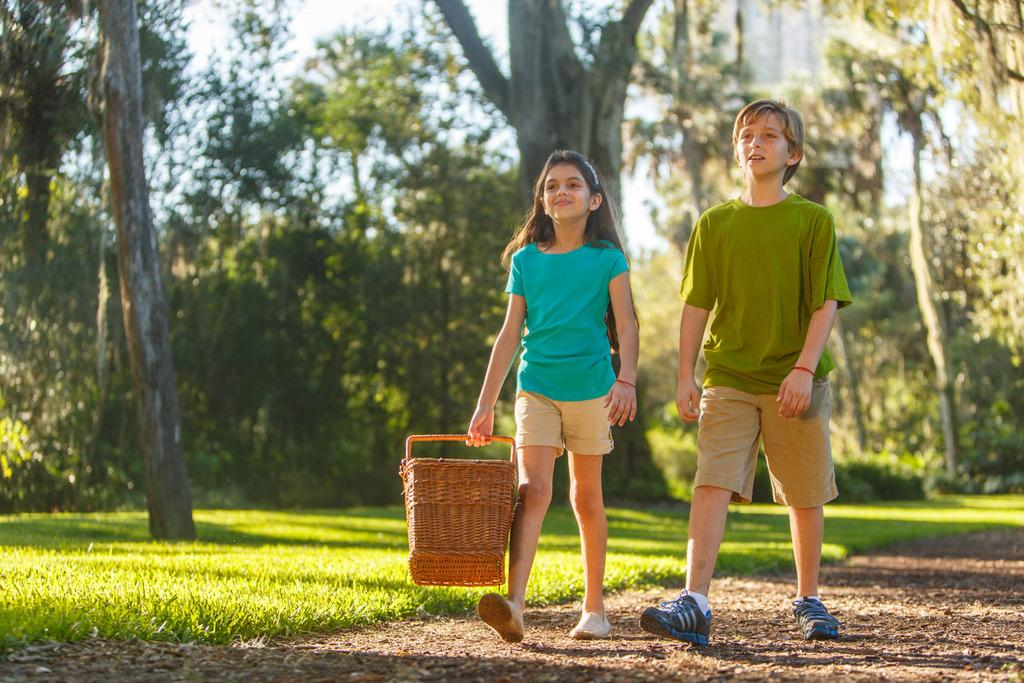Who are the two people in the image? There is a boy and a girl in the image. What are they doing in the image? The boy and girl are carrying a basket in the image. What is the surface they are walking on? They are walking on the ground in the image. What can be seen in the background of the image? There are many trees and grass visible in the background of the image. Where is the lamp placed in the image? There is no lamp present in the image. What type of bit is the girl taking in the image? There is no bit present in the image, as the girl is carrying a basket, not eating or chewing anything. 